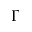Convert formula to latex. <formula><loc_0><loc_0><loc_500><loc_500>\Gamma</formula> 